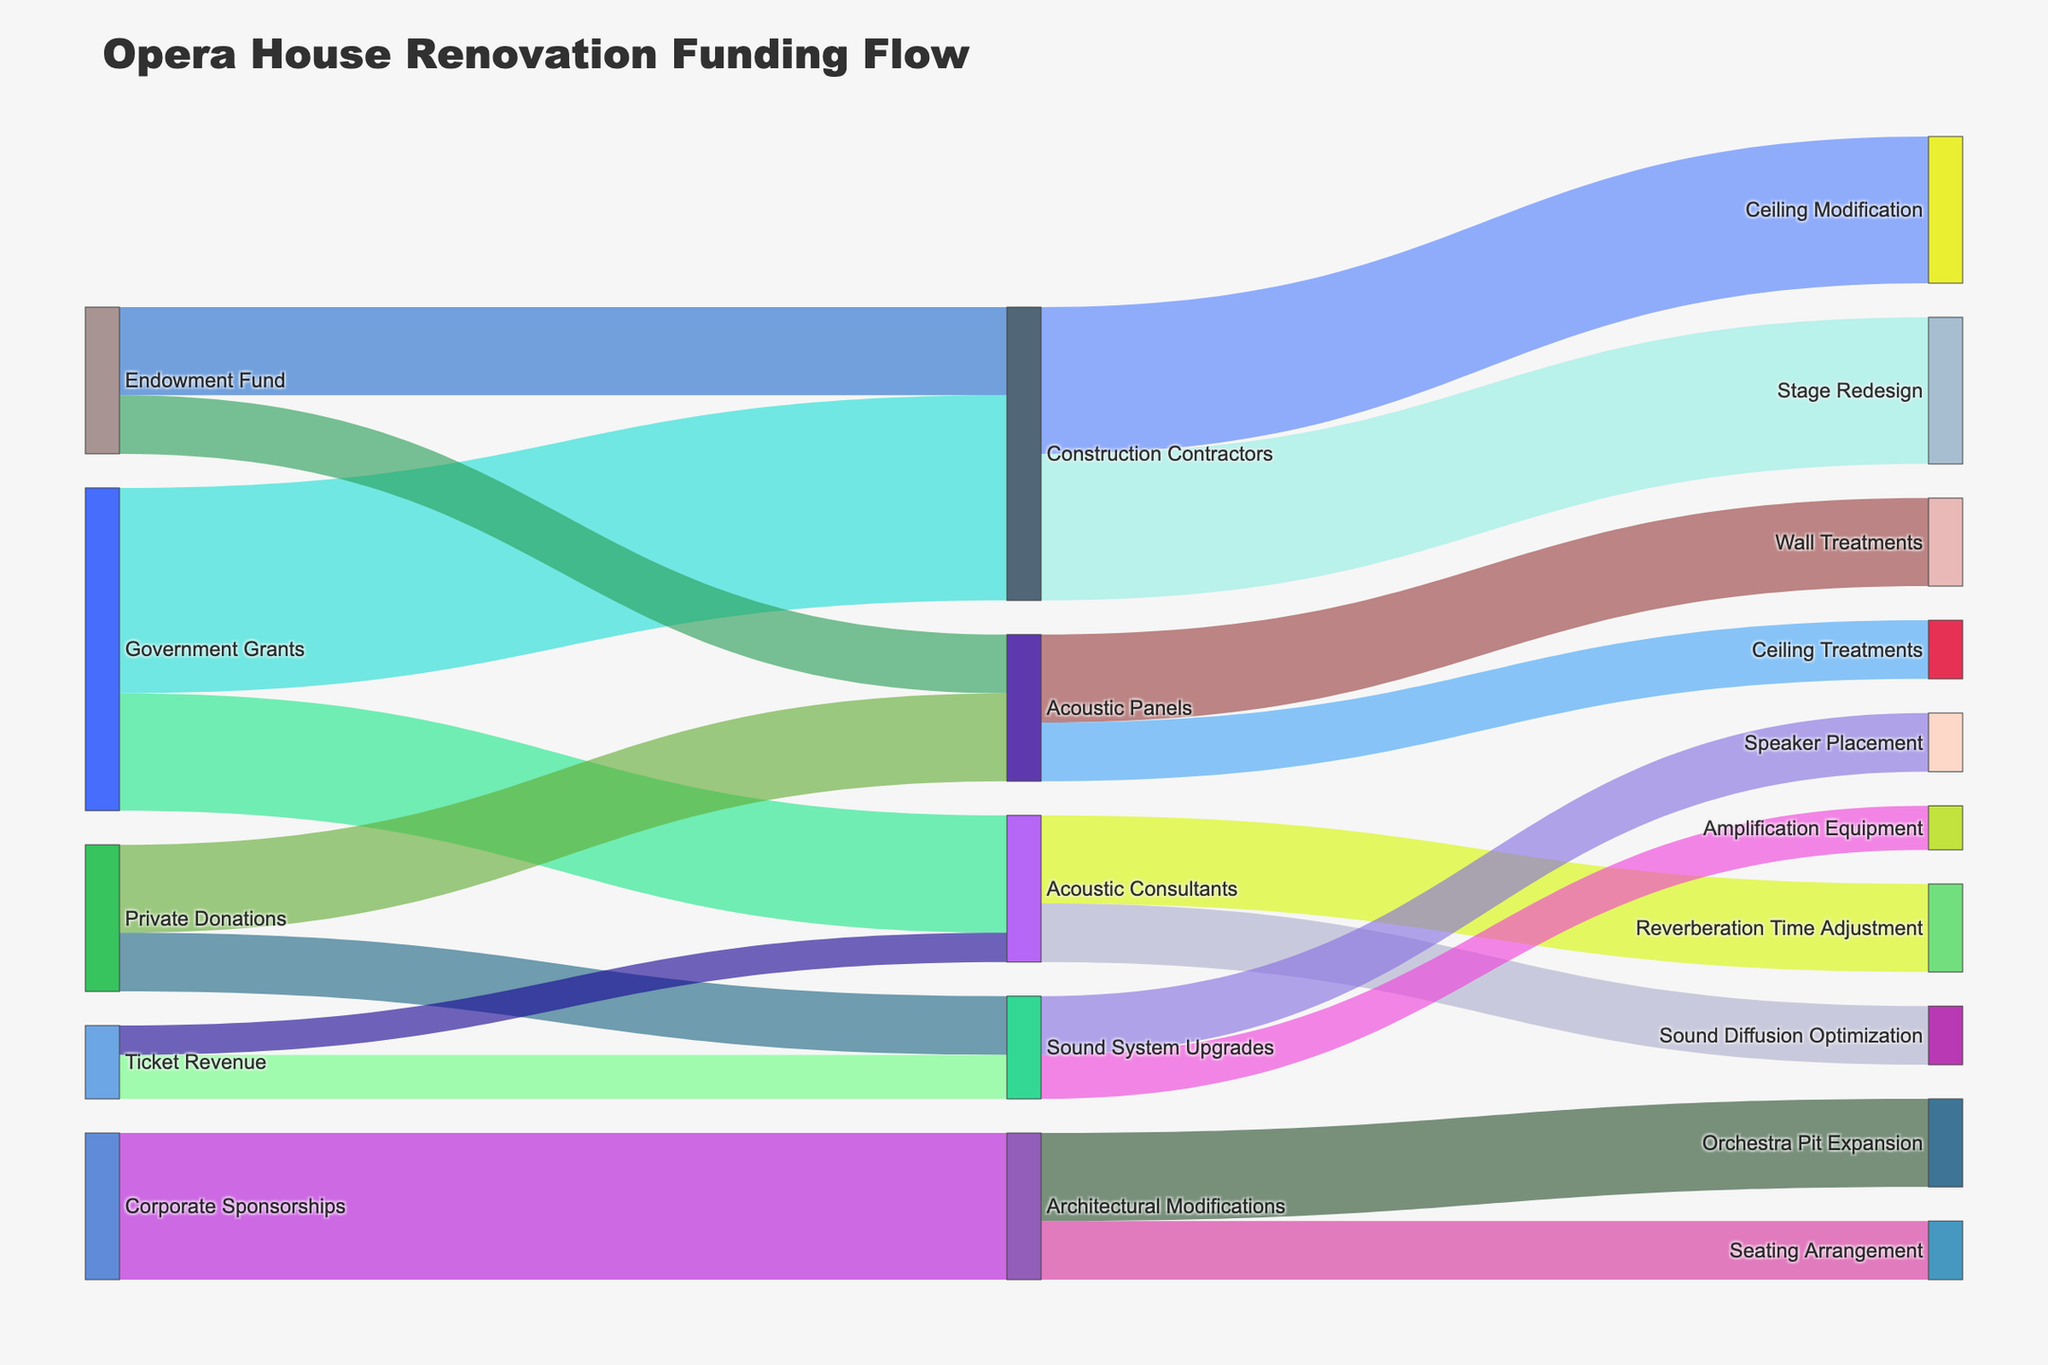What is the title of the figure? The title is located at the top of the figure.
Answer: Opera House Renovation Funding Flow How much funding did Government Grants allocate to Acoustic Consultants? Trace the flow from "Government Grants" to "Acoustic Consultants" in the Sankey diagram.
Answer: $2,000,000 Which source provided the most funding to Construction Contractors? Compare the values from all sources flowing to "Construction Contractors" and identify the highest one.
Answer: Government Grants What is the total amount of funding provided by Private Donations? Add the amounts flowing from "Private Donations" to all targets: $1,500,000 (Acoustic Panels) + $1,000,000 (Sound System Upgrades).
Answer: $2,500,000 Which target received the least funding from all sources? Identify the target node with the smallest cumulative incoming flow.
Answer: Sound Diffusion Optimization How much funding did Ticket Revenue allocate to both Acoustic Consultants and Sound System Upgrades combined? Sum the values flowing from "Ticket Revenue" to "Acoustic Consultants" and "Sound System Upgrades": $500,000 + $750,000.
Answer: $1,250,000 How does the funding for Reverberation Time Adjustment compare to Sound Diffusion Optimization from Acoustic Consultants? Look at the flows from "Acoustic Consultants" to "Reverberation Time Adjustment" and "Sound Diffusion Optimization"; compare their values.
Answer: Reverberation Time Adjustment received $500,000 more How is the funding from Architectural Modifications distributed across its targets? List the targets and their corresponding values from "Architectural Modifications": Orchestra Pit Expansion and Seating Arrangement.
Answer: Orchestra Pit Expansion ($1,500,000), Seating Arrangement ($1,000,000) What is the purpose of Government Grants allocated to Acoustic Consultants? Trace the flow from "Acoustic Consultants" to its subsequent nodes to see how the funds are used.
Answer: Reverberation Time Adjustment and Sound Diffusion Optimization 